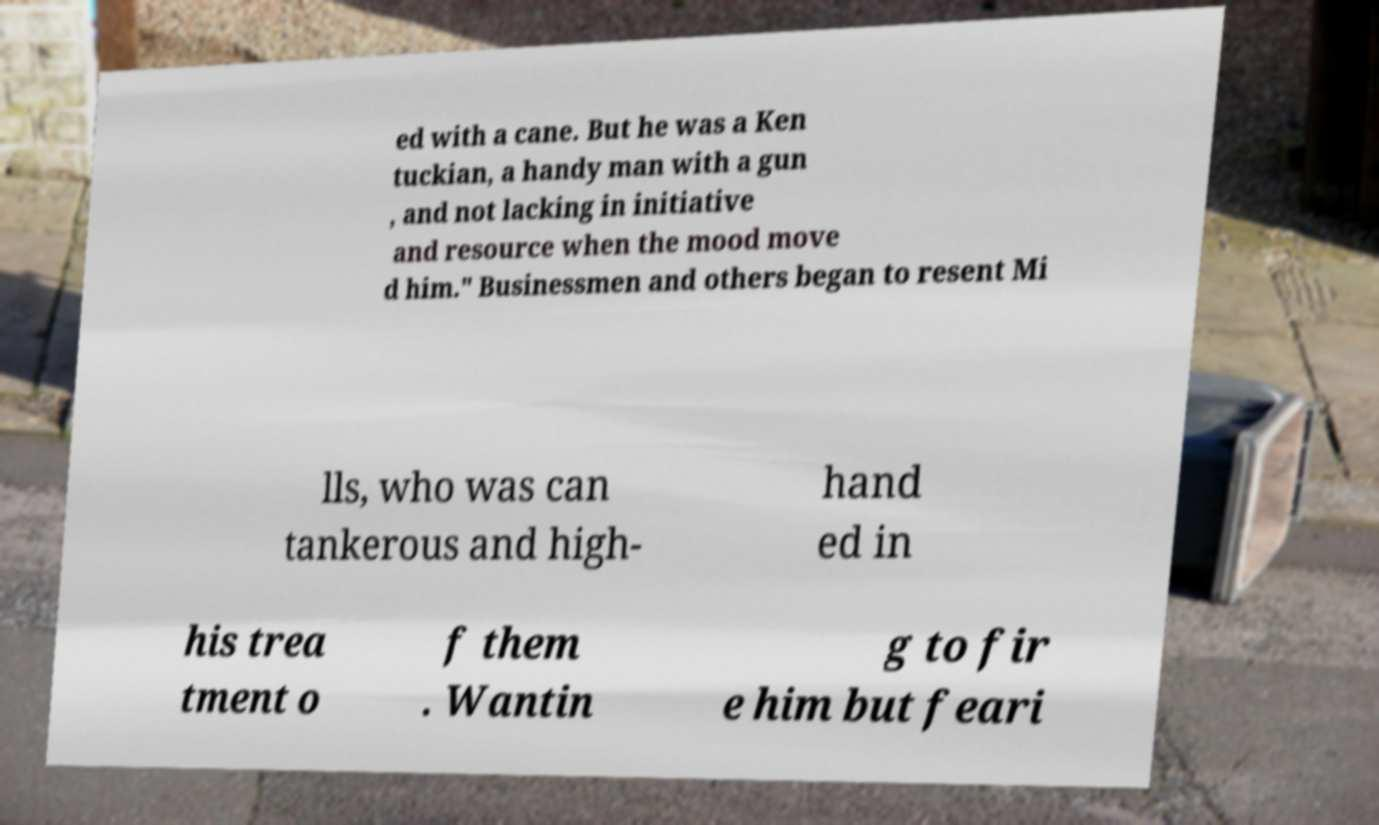Can you read and provide the text displayed in the image?This photo seems to have some interesting text. Can you extract and type it out for me? ed with a cane. But he was a Ken tuckian, a handy man with a gun , and not lacking in initiative and resource when the mood move d him." Businessmen and others began to resent Mi lls, who was can tankerous and high- hand ed in his trea tment o f them . Wantin g to fir e him but feari 